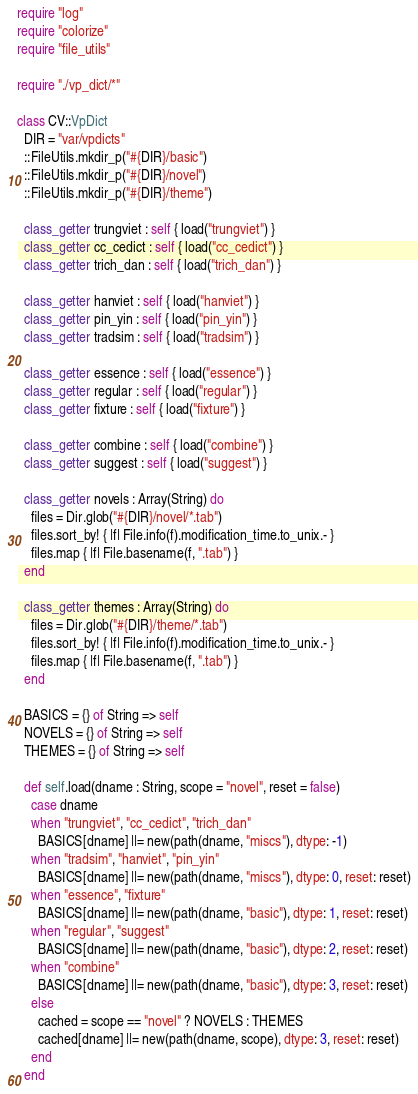<code> <loc_0><loc_0><loc_500><loc_500><_Crystal_>require "log"
require "colorize"
require "file_utils"

require "./vp_dict/*"

class CV::VpDict
  DIR = "var/vpdicts"
  ::FileUtils.mkdir_p("#{DIR}/basic")
  ::FileUtils.mkdir_p("#{DIR}/novel")
  ::FileUtils.mkdir_p("#{DIR}/theme")

  class_getter trungviet : self { load("trungviet") }
  class_getter cc_cedict : self { load("cc_cedict") }
  class_getter trich_dan : self { load("trich_dan") }

  class_getter hanviet : self { load("hanviet") }
  class_getter pin_yin : self { load("pin_yin") }
  class_getter tradsim : self { load("tradsim") }

  class_getter essence : self { load("essence") }
  class_getter regular : self { load("regular") }
  class_getter fixture : self { load("fixture") }

  class_getter combine : self { load("combine") }
  class_getter suggest : self { load("suggest") }

  class_getter novels : Array(String) do
    files = Dir.glob("#{DIR}/novel/*.tab")
    files.sort_by! { |f| File.info(f).modification_time.to_unix.- }
    files.map { |f| File.basename(f, ".tab") }
  end

  class_getter themes : Array(String) do
    files = Dir.glob("#{DIR}/theme/*.tab")
    files.sort_by! { |f| File.info(f).modification_time.to_unix.- }
    files.map { |f| File.basename(f, ".tab") }
  end

  BASICS = {} of String => self
  NOVELS = {} of String => self
  THEMES = {} of String => self

  def self.load(dname : String, scope = "novel", reset = false)
    case dname
    when "trungviet", "cc_cedict", "trich_dan"
      BASICS[dname] ||= new(path(dname, "miscs"), dtype: -1)
    when "tradsim", "hanviet", "pin_yin"
      BASICS[dname] ||= new(path(dname, "miscs"), dtype: 0, reset: reset)
    when "essence", "fixture"
      BASICS[dname] ||= new(path(dname, "basic"), dtype: 1, reset: reset)
    when "regular", "suggest"
      BASICS[dname] ||= new(path(dname, "basic"), dtype: 2, reset: reset)
    when "combine"
      BASICS[dname] ||= new(path(dname, "basic"), dtype: 3, reset: reset)
    else
      cached = scope == "novel" ? NOVELS : THEMES
      cached[dname] ||= new(path(dname, scope), dtype: 3, reset: reset)
    end
  end
</code> 